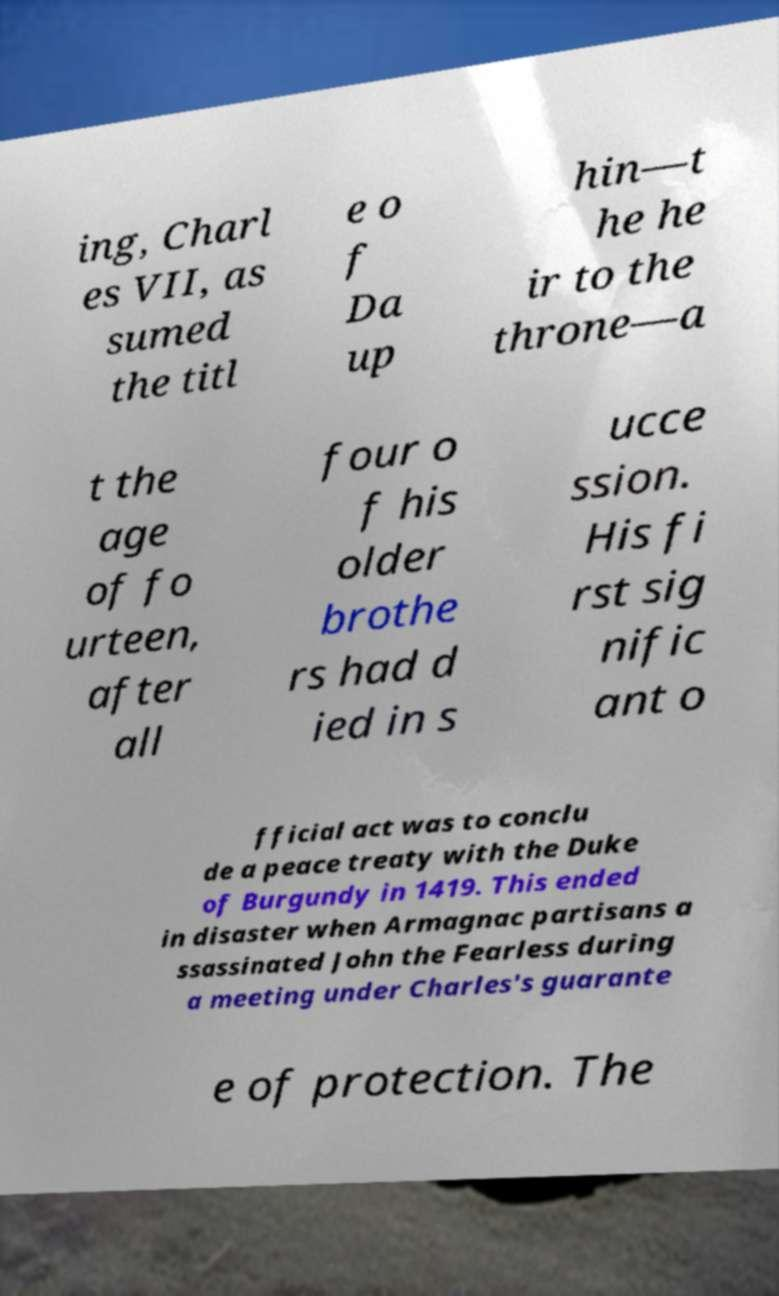I need the written content from this picture converted into text. Can you do that? ing, Charl es VII, as sumed the titl e o f Da up hin—t he he ir to the throne—a t the age of fo urteen, after all four o f his older brothe rs had d ied in s ucce ssion. His fi rst sig nific ant o fficial act was to conclu de a peace treaty with the Duke of Burgundy in 1419. This ended in disaster when Armagnac partisans a ssassinated John the Fearless during a meeting under Charles's guarante e of protection. The 